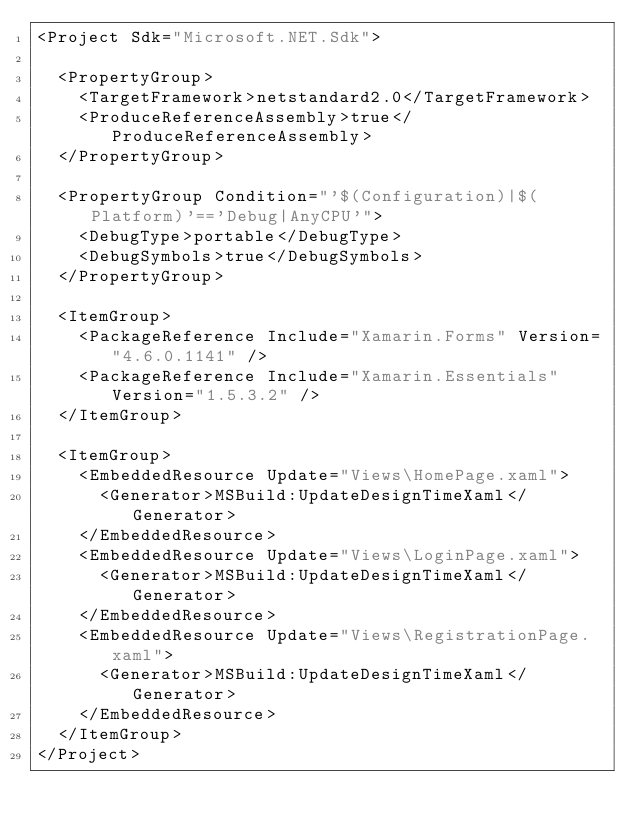<code> <loc_0><loc_0><loc_500><loc_500><_XML_><Project Sdk="Microsoft.NET.Sdk">

  <PropertyGroup>
    <TargetFramework>netstandard2.0</TargetFramework>
    <ProduceReferenceAssembly>true</ProduceReferenceAssembly>
  </PropertyGroup>

  <PropertyGroup Condition="'$(Configuration)|$(Platform)'=='Debug|AnyCPU'">
    <DebugType>portable</DebugType>
    <DebugSymbols>true</DebugSymbols>
  </PropertyGroup>

  <ItemGroup>
    <PackageReference Include="Xamarin.Forms" Version="4.6.0.1141" />
    <PackageReference Include="Xamarin.Essentials" Version="1.5.3.2" />
  </ItemGroup>

  <ItemGroup>
    <EmbeddedResource Update="Views\HomePage.xaml">
      <Generator>MSBuild:UpdateDesignTimeXaml</Generator>
    </EmbeddedResource>
    <EmbeddedResource Update="Views\LoginPage.xaml">
      <Generator>MSBuild:UpdateDesignTimeXaml</Generator>
    </EmbeddedResource>
    <EmbeddedResource Update="Views\RegistrationPage.xaml">
      <Generator>MSBuild:UpdateDesignTimeXaml</Generator>
    </EmbeddedResource>
  </ItemGroup>
</Project></code> 